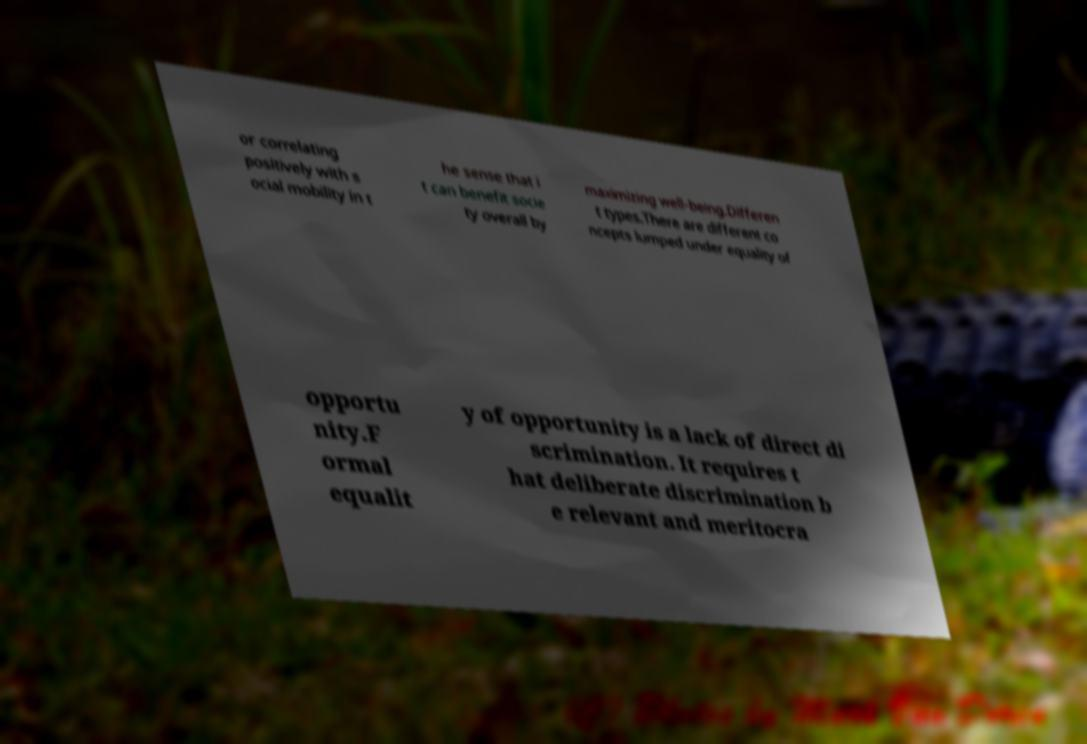Please identify and transcribe the text found in this image. or correlating positively with s ocial mobility in t he sense that i t can benefit socie ty overall by maximizing well-being.Differen t types.There are different co ncepts lumped under equality of opportu nity.F ormal equalit y of opportunity is a lack of direct di scrimination. It requires t hat deliberate discrimination b e relevant and meritocra 